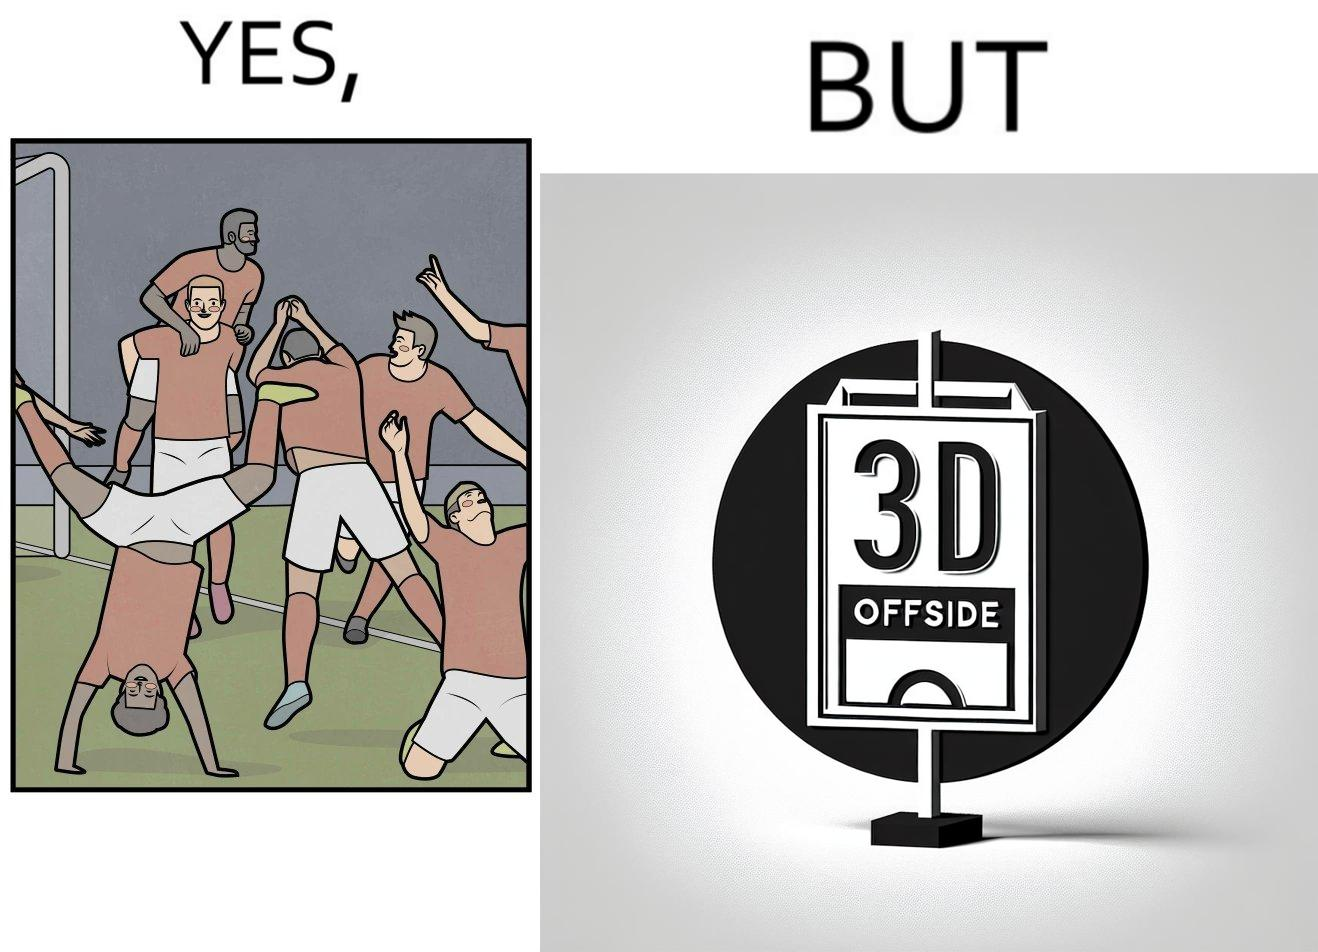What makes this image funny or satirical? The image is ironical, as the team is celebrating as they think that they have scored a goal, but the sign on the screen says that it is an offside, and not a goal. This is a very common scenario in football matches. 